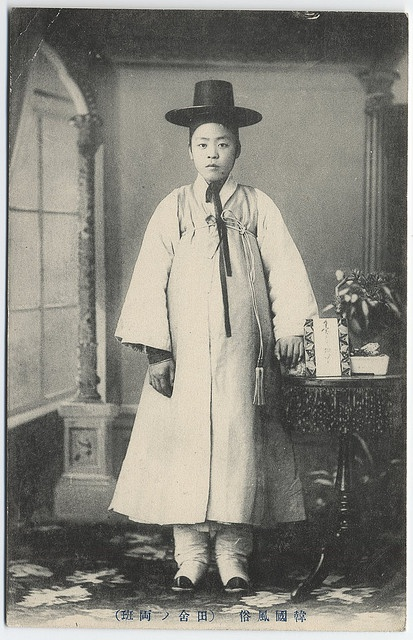Describe the objects in this image and their specific colors. I can see people in lightgray, gray, and darkgray tones, potted plant in lightgray, gray, black, and darkgray tones, potted plant in lightgray, gray, and darkgray tones, tie in lightgray, gray, black, and darkgray tones, and tie in lightgray, gray, black, and darkgray tones in this image. 